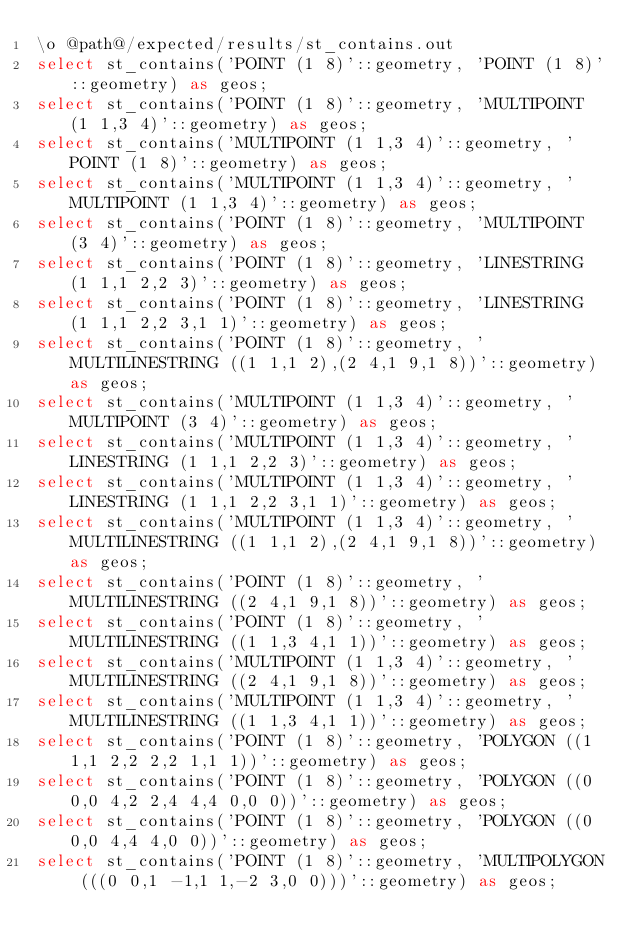Convert code to text. <code><loc_0><loc_0><loc_500><loc_500><_SQL_>\o @path@/expected/results/st_contains.out
select st_contains('POINT (1 8)'::geometry, 'POINT (1 8)'::geometry) as geos;
select st_contains('POINT (1 8)'::geometry, 'MULTIPOINT (1 1,3 4)'::geometry) as geos;
select st_contains('MULTIPOINT (1 1,3 4)'::geometry, 'POINT (1 8)'::geometry) as geos;
select st_contains('MULTIPOINT (1 1,3 4)'::geometry, 'MULTIPOINT (1 1,3 4)'::geometry) as geos;
select st_contains('POINT (1 8)'::geometry, 'MULTIPOINT (3 4)'::geometry) as geos;
select st_contains('POINT (1 8)'::geometry, 'LINESTRING (1 1,1 2,2 3)'::geometry) as geos;
select st_contains('POINT (1 8)'::geometry, 'LINESTRING (1 1,1 2,2 3,1 1)'::geometry) as geos;
select st_contains('POINT (1 8)'::geometry, 'MULTILINESTRING ((1 1,1 2),(2 4,1 9,1 8))'::geometry) as geos;
select st_contains('MULTIPOINT (1 1,3 4)'::geometry, 'MULTIPOINT (3 4)'::geometry) as geos;
select st_contains('MULTIPOINT (1 1,3 4)'::geometry, 'LINESTRING (1 1,1 2,2 3)'::geometry) as geos;
select st_contains('MULTIPOINT (1 1,3 4)'::geometry, 'LINESTRING (1 1,1 2,2 3,1 1)'::geometry) as geos;
select st_contains('MULTIPOINT (1 1,3 4)'::geometry, 'MULTILINESTRING ((1 1,1 2),(2 4,1 9,1 8))'::geometry) as geos;
select st_contains('POINT (1 8)'::geometry, 'MULTILINESTRING ((2 4,1 9,1 8))'::geometry) as geos;
select st_contains('POINT (1 8)'::geometry, 'MULTILINESTRING ((1 1,3 4,1 1))'::geometry) as geos;
select st_contains('MULTIPOINT (1 1,3 4)'::geometry, 'MULTILINESTRING ((2 4,1 9,1 8))'::geometry) as geos;
select st_contains('MULTIPOINT (1 1,3 4)'::geometry, 'MULTILINESTRING ((1 1,3 4,1 1))'::geometry) as geos;
select st_contains('POINT (1 8)'::geometry, 'POLYGON ((1 1,1 2,2 2,2 1,1 1))'::geometry) as geos;
select st_contains('POINT (1 8)'::geometry, 'POLYGON ((0 0,0 4,2 2,4 4,4 0,0 0))'::geometry) as geos;
select st_contains('POINT (1 8)'::geometry, 'POLYGON ((0 0,0 4,4 4,0 0))'::geometry) as geos;
select st_contains('POINT (1 8)'::geometry, 'MULTIPOLYGON (((0 0,1 -1,1 1,-2 3,0 0)))'::geometry) as geos;</code> 